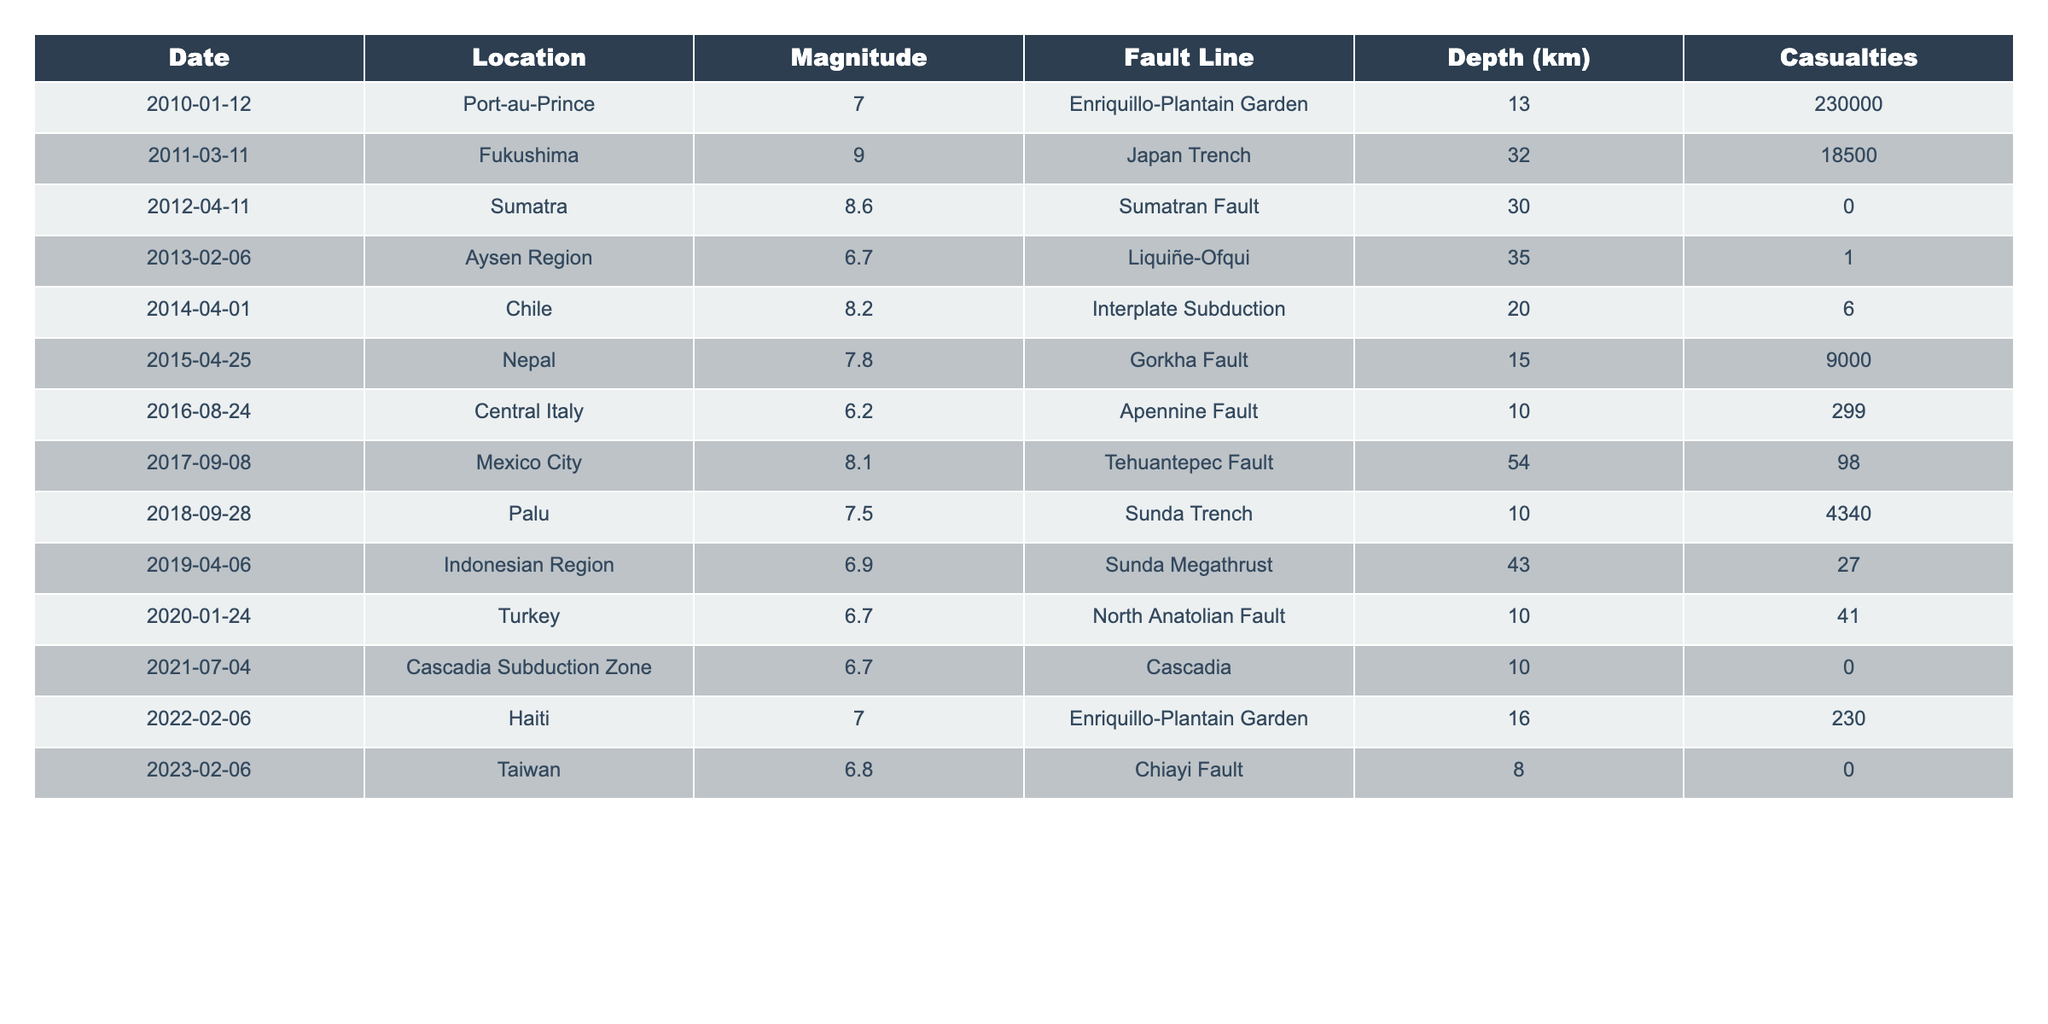What was the highest magnitude recorded in the table? The table shows multiple magnitudes, and the maximum value is found in the second row, which is 9.0 during the Fukushima earthquake.
Answer: 9.0 Which fault line experienced the most casualties? By reviewing the casualty figures for each row, the Enriquillo-Plantain Garden fault line is noted for having the highest casualties (230,000) during the Port-au-Prince earthquake in 2010.
Answer: Enriquillo-Plantain Garden How many earthquakes occurred along the Sumatran Fault? Looking at the table, the Sumatran Fault appears once with an earthquake magnitude of 8.6 in 2012.
Answer: 1 What is the average depth of the earthquakes listed? Adding the depths of all earthquakes (13 + 32 + 30 + 35 + 20 + 15 + 10 + 54 + 10 + 43 + 10 + 16 + 8) results in a total of  392 km. There are 13 earthquakes, so the average depth is 392 / 13 ≈ 30.15 km.
Answer: Approximately 30.15 km Did any earthquake have zero casualties, and if so, how many? Checking the casualties column, the earthquakes in Sumatra (2012) and Taiwan (2023) show 0 casualties, indicating that there were 2 such instances.
Answer: Yes, 2 What is the difference in casualties between the highest and lowest recorded? The highest casualties are 230,000 from the Port-au-Prince earthquake, while the lowest is 0 from Sumatra (2012) and Taiwan (2023). The difference is thus 230,000 - 0 = 230,000.
Answer: 230,000 How many earthquakes had a magnitude greater than 7.5? By scanning through the table, the earthquakes that have magnitudes greater than 7.5 are the ones in Port-au-Prince, Fukushima, Sumatra, Chile, Nepal, and Mexico City, totaling 6 occurrences.
Answer: 6 What was the average magnitude of earthquakes that occurred along the North Anatolian Fault? Only one earthquake is listed for the North Anatolian Fault, which occurred in Turkey with a magnitude of 6.7. Since there is only one instance, the average is simply 6.7.
Answer: 6.7 Which year had the highest magnitude earthquake, and what was it? The highest magnitude earthquake recorded in the table in the year 2011 was 9.0 during the Fukushima event.
Answer: 2011, 9.0 Was there an earthquake recorded in 2021 with casualties? Checking the table for 2021 shows the Cascadia Subduction Zone event, which had 0 casualties; therefore, there were no casualties recorded for 2021.
Answer: No 